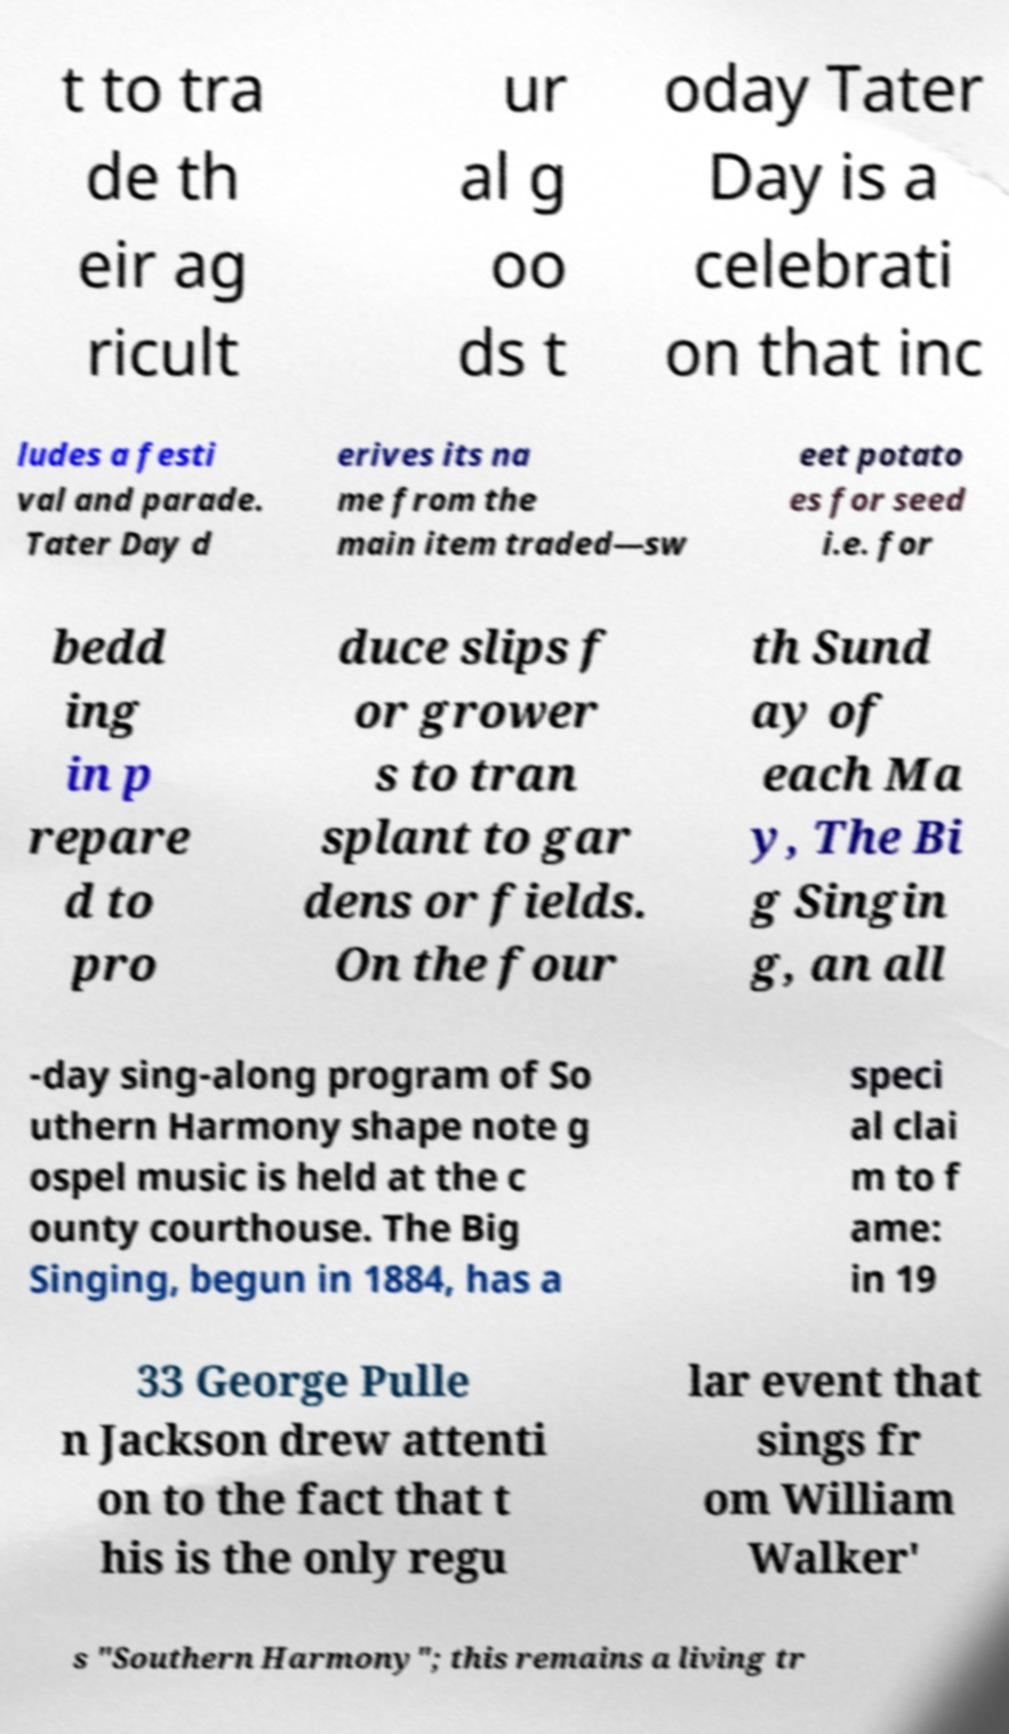Could you extract and type out the text from this image? t to tra de th eir ag ricult ur al g oo ds t oday Tater Day is a celebrati on that inc ludes a festi val and parade. Tater Day d erives its na me from the main item traded—sw eet potato es for seed i.e. for bedd ing in p repare d to pro duce slips f or grower s to tran splant to gar dens or fields. On the four th Sund ay of each Ma y, The Bi g Singin g, an all -day sing-along program of So uthern Harmony shape note g ospel music is held at the c ounty courthouse. The Big Singing, begun in 1884, has a speci al clai m to f ame: in 19 33 George Pulle n Jackson drew attenti on to the fact that t his is the only regu lar event that sings fr om William Walker' s "Southern Harmony"; this remains a living tr 